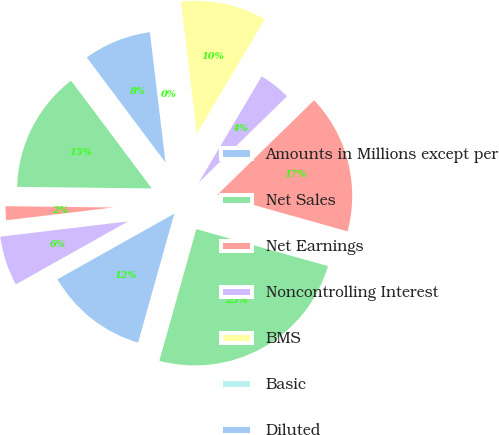Convert chart. <chart><loc_0><loc_0><loc_500><loc_500><pie_chart><fcel>Amounts in Millions except per<fcel>Net Sales<fcel>Net Earnings<fcel>Noncontrolling Interest<fcel>BMS<fcel>Basic<fcel>Diluted<fcel>Cash dividends paid on BMS<fcel>Cash dividends declared per<fcel>Cash and cash equivalents<nl><fcel>12.5%<fcel>25.0%<fcel>16.67%<fcel>4.17%<fcel>10.42%<fcel>0.0%<fcel>8.33%<fcel>14.58%<fcel>2.08%<fcel>6.25%<nl></chart> 